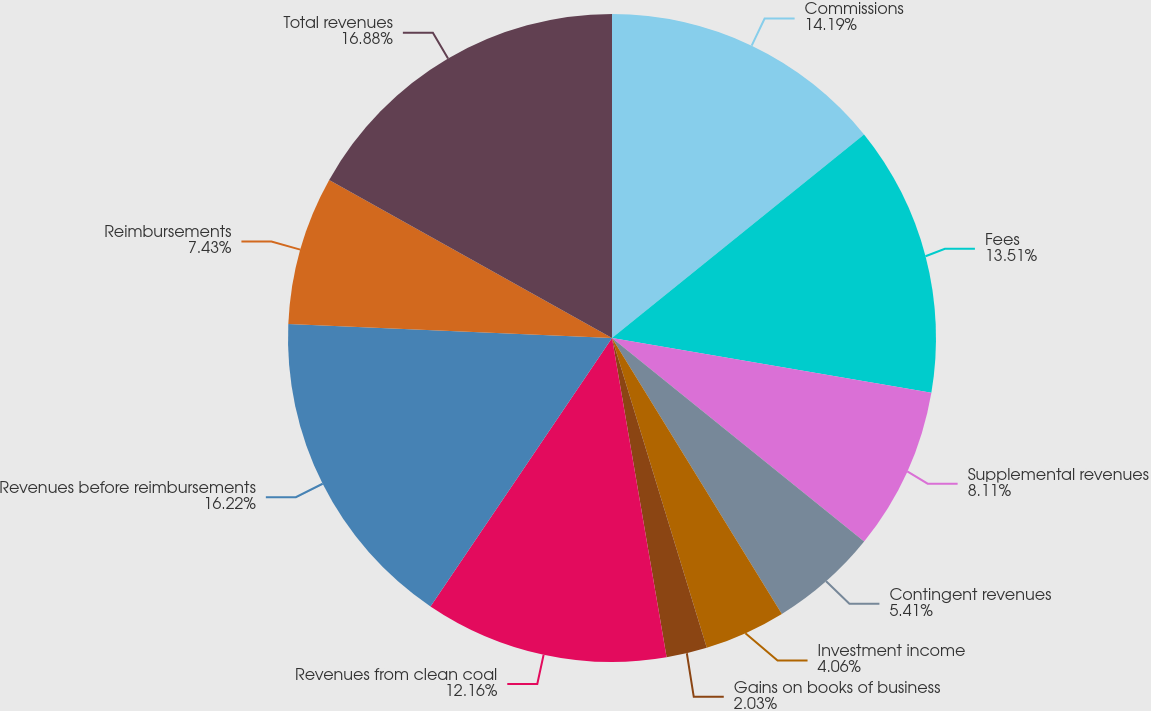Convert chart. <chart><loc_0><loc_0><loc_500><loc_500><pie_chart><fcel>Commissions<fcel>Fees<fcel>Supplemental revenues<fcel>Contingent revenues<fcel>Investment income<fcel>Gains on books of business<fcel>Revenues from clean coal<fcel>Revenues before reimbursements<fcel>Reimbursements<fcel>Total revenues<nl><fcel>14.19%<fcel>13.51%<fcel>8.11%<fcel>5.41%<fcel>4.06%<fcel>2.03%<fcel>12.16%<fcel>16.22%<fcel>7.43%<fcel>16.89%<nl></chart> 